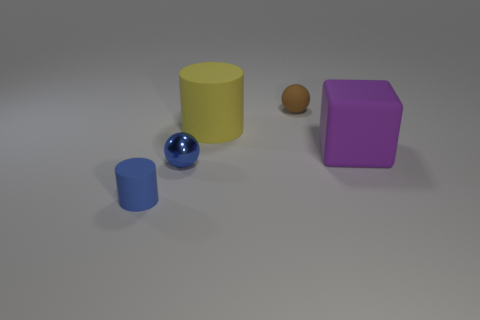Add 4 brown things. How many objects exist? 9 Subtract all cubes. How many objects are left? 4 Add 1 brown metallic spheres. How many brown metallic spheres exist? 1 Subtract 0 purple balls. How many objects are left? 5 Subtract all large purple matte things. Subtract all large purple things. How many objects are left? 3 Add 2 big yellow cylinders. How many big yellow cylinders are left? 3 